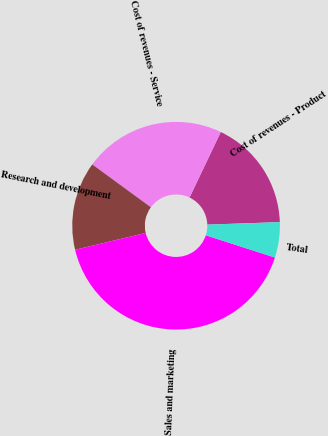Convert chart to OTSL. <chart><loc_0><loc_0><loc_500><loc_500><pie_chart><fcel>Cost of revenues - Product<fcel>Cost of revenues - Service<fcel>Research and development<fcel>Sales and marketing<fcel>Total<nl><fcel>17.36%<fcel>22.04%<fcel>13.77%<fcel>41.32%<fcel>5.51%<nl></chart> 